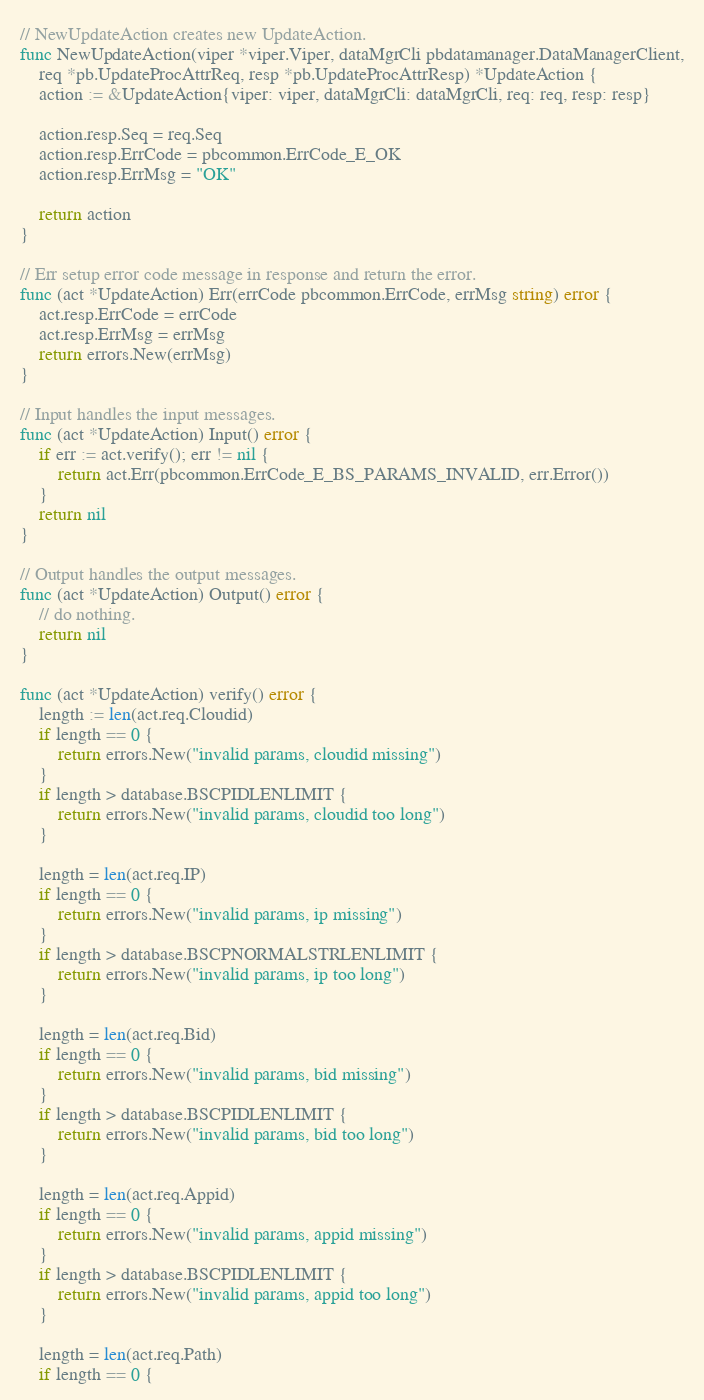<code> <loc_0><loc_0><loc_500><loc_500><_Go_>
// NewUpdateAction creates new UpdateAction.
func NewUpdateAction(viper *viper.Viper, dataMgrCli pbdatamanager.DataManagerClient,
	req *pb.UpdateProcAttrReq, resp *pb.UpdateProcAttrResp) *UpdateAction {
	action := &UpdateAction{viper: viper, dataMgrCli: dataMgrCli, req: req, resp: resp}

	action.resp.Seq = req.Seq
	action.resp.ErrCode = pbcommon.ErrCode_E_OK
	action.resp.ErrMsg = "OK"

	return action
}

// Err setup error code message in response and return the error.
func (act *UpdateAction) Err(errCode pbcommon.ErrCode, errMsg string) error {
	act.resp.ErrCode = errCode
	act.resp.ErrMsg = errMsg
	return errors.New(errMsg)
}

// Input handles the input messages.
func (act *UpdateAction) Input() error {
	if err := act.verify(); err != nil {
		return act.Err(pbcommon.ErrCode_E_BS_PARAMS_INVALID, err.Error())
	}
	return nil
}

// Output handles the output messages.
func (act *UpdateAction) Output() error {
	// do nothing.
	return nil
}

func (act *UpdateAction) verify() error {
	length := len(act.req.Cloudid)
	if length == 0 {
		return errors.New("invalid params, cloudid missing")
	}
	if length > database.BSCPIDLENLIMIT {
		return errors.New("invalid params, cloudid too long")
	}

	length = len(act.req.IP)
	if length == 0 {
		return errors.New("invalid params, ip missing")
	}
	if length > database.BSCPNORMALSTRLENLIMIT {
		return errors.New("invalid params, ip too long")
	}

	length = len(act.req.Bid)
	if length == 0 {
		return errors.New("invalid params, bid missing")
	}
	if length > database.BSCPIDLENLIMIT {
		return errors.New("invalid params, bid too long")
	}

	length = len(act.req.Appid)
	if length == 0 {
		return errors.New("invalid params, appid missing")
	}
	if length > database.BSCPIDLENLIMIT {
		return errors.New("invalid params, appid too long")
	}

	length = len(act.req.Path)
	if length == 0 {</code> 